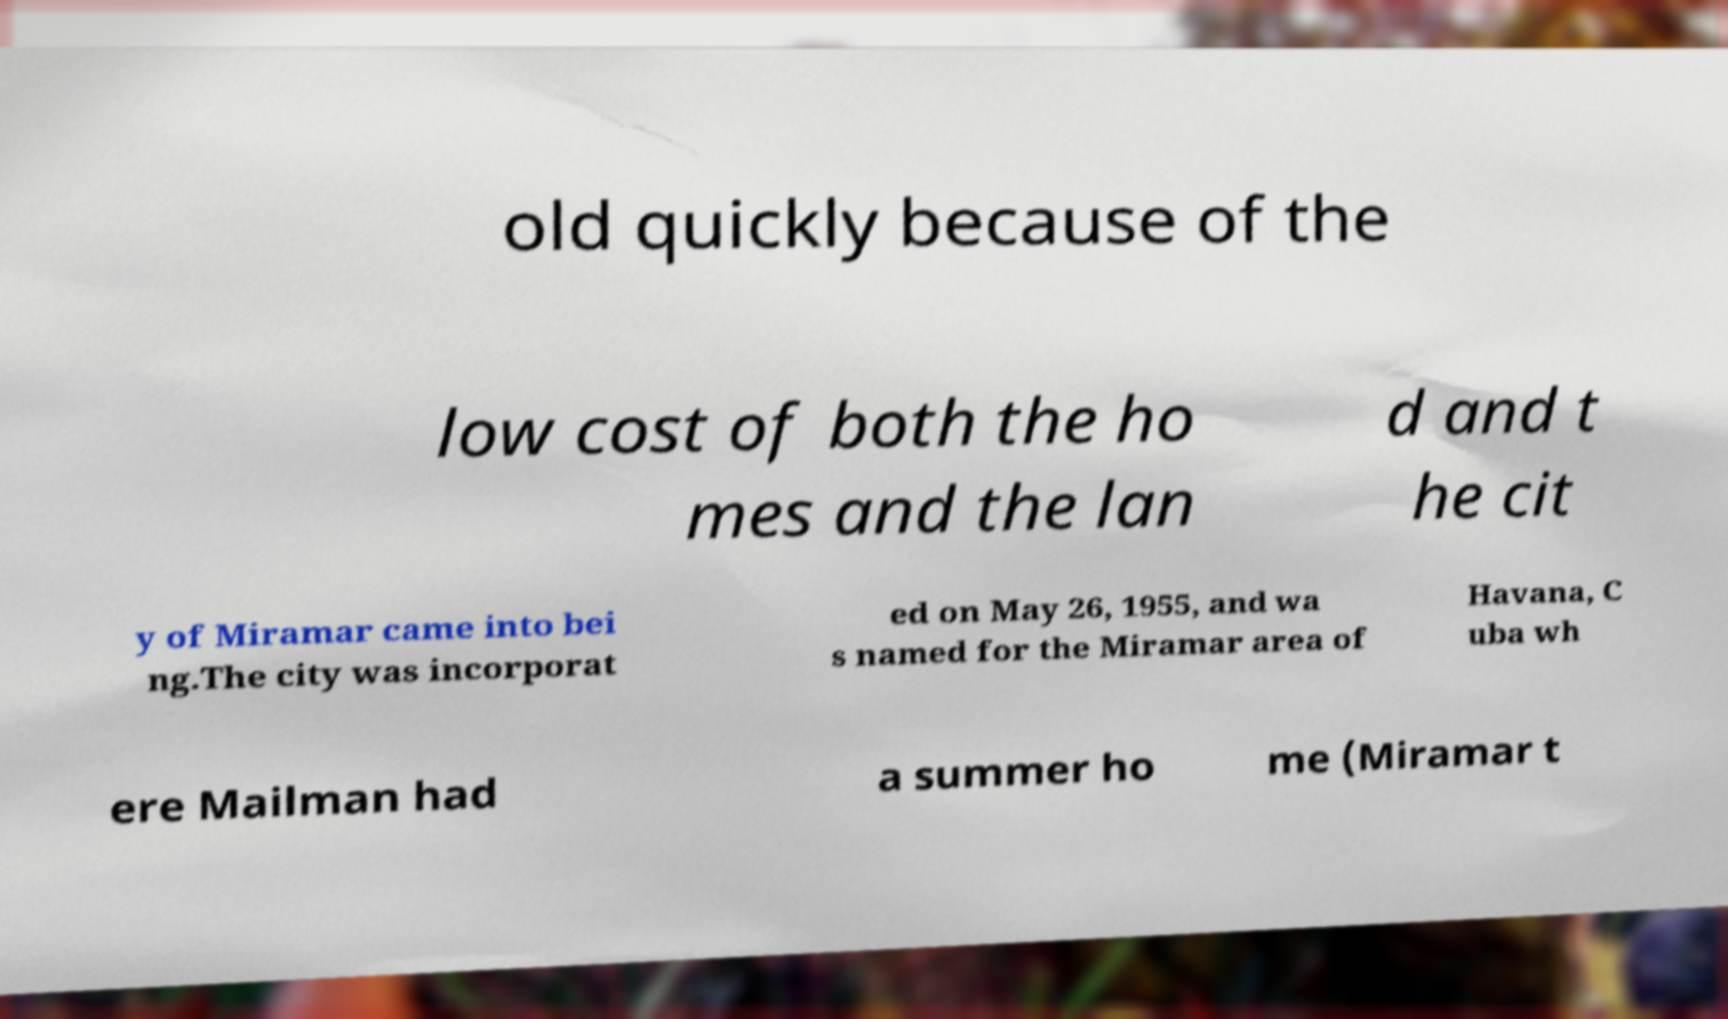Can you accurately transcribe the text from the provided image for me? old quickly because of the low cost of both the ho mes and the lan d and t he cit y of Miramar came into bei ng.The city was incorporat ed on May 26, 1955, and wa s named for the Miramar area of Havana, C uba wh ere Mailman had a summer ho me (Miramar t 